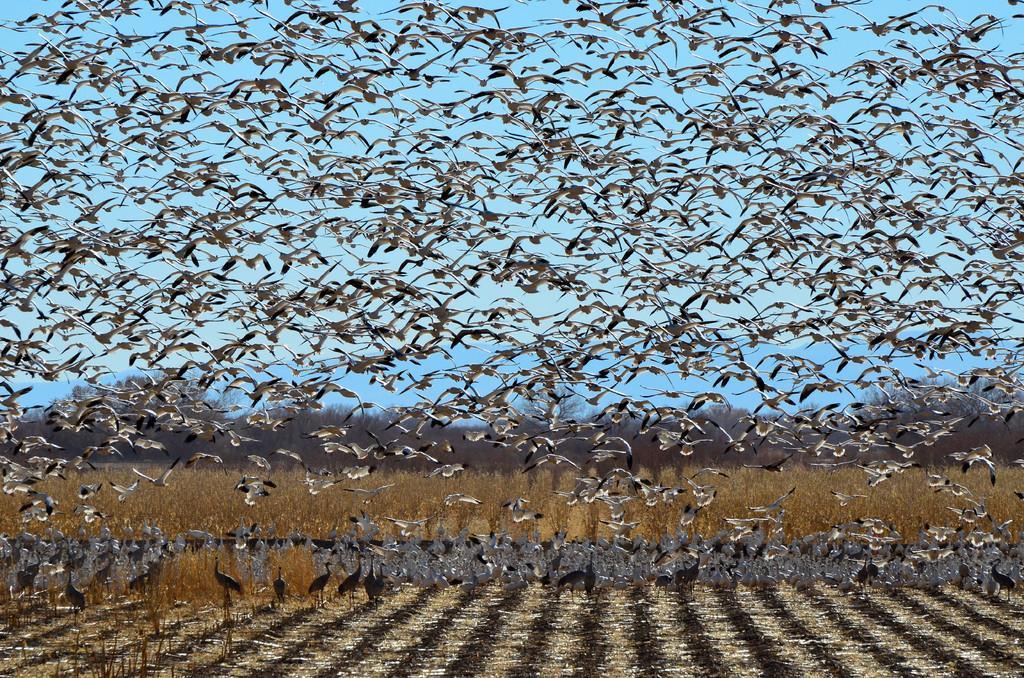In one or two sentences, can you explain what this image depicts? In this image we can see there are few birds flying in the sky and few birds standing on the ground. At the back there are plants and trees. 